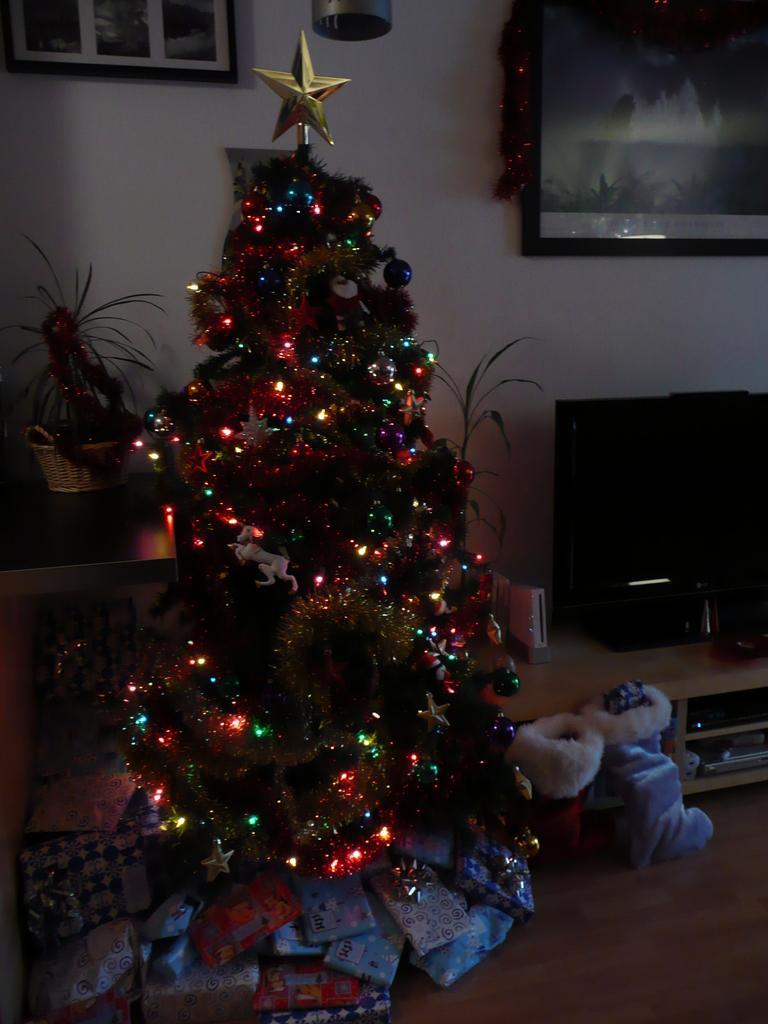Can you describe this image briefly? In this image we can see decorative items on a tree. At the bottom we can see gifts and objects on the floor. There is a TV and objects on the table, frames on the wall and on the left side there is a plant in a basket on a platform. 